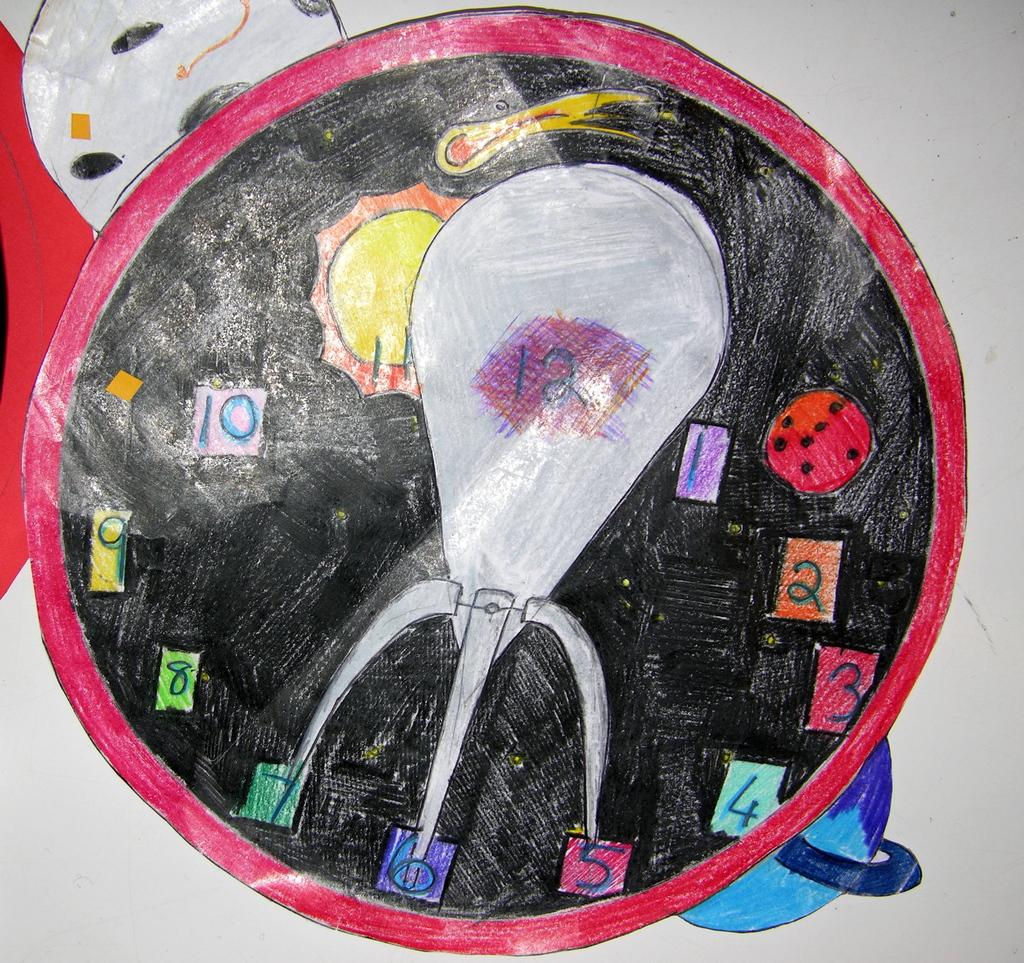What is present on the paper in the image? The paper has a painting on it. What can be seen in the painting on the paper? There are objects painted on the paper. Are there any numerical elements on the paper? Yes, there are numbers on the paper. Can you see a dog playing with a twig in the painting on the paper? There is no dog or twig present in the painting on the paper; it features objects other than those mentioned. 